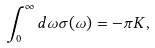<formula> <loc_0><loc_0><loc_500><loc_500>\int _ { 0 } ^ { \infty } d \omega \sigma ( \omega ) = - \pi K ,</formula> 